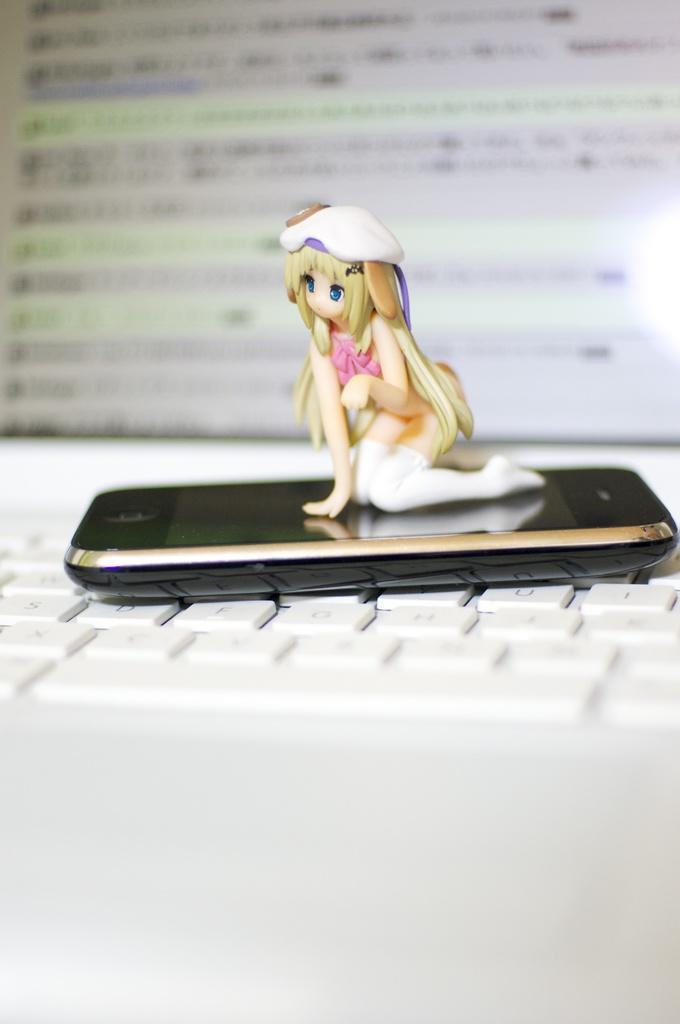What electronic device is the main subject of the image? There is a laptop in the image. What feature is present on the laptop? The laptop has a keyboard. What other object is placed on the laptop? There is a mobile phone on the keyboard. What is on top of the mobile phone? There is a toy on the mobile phone. What type of shirt is the actor wearing in the image? There is no actor or shirt present in the image; it features a laptop with a mobile phone and a toy on top. 